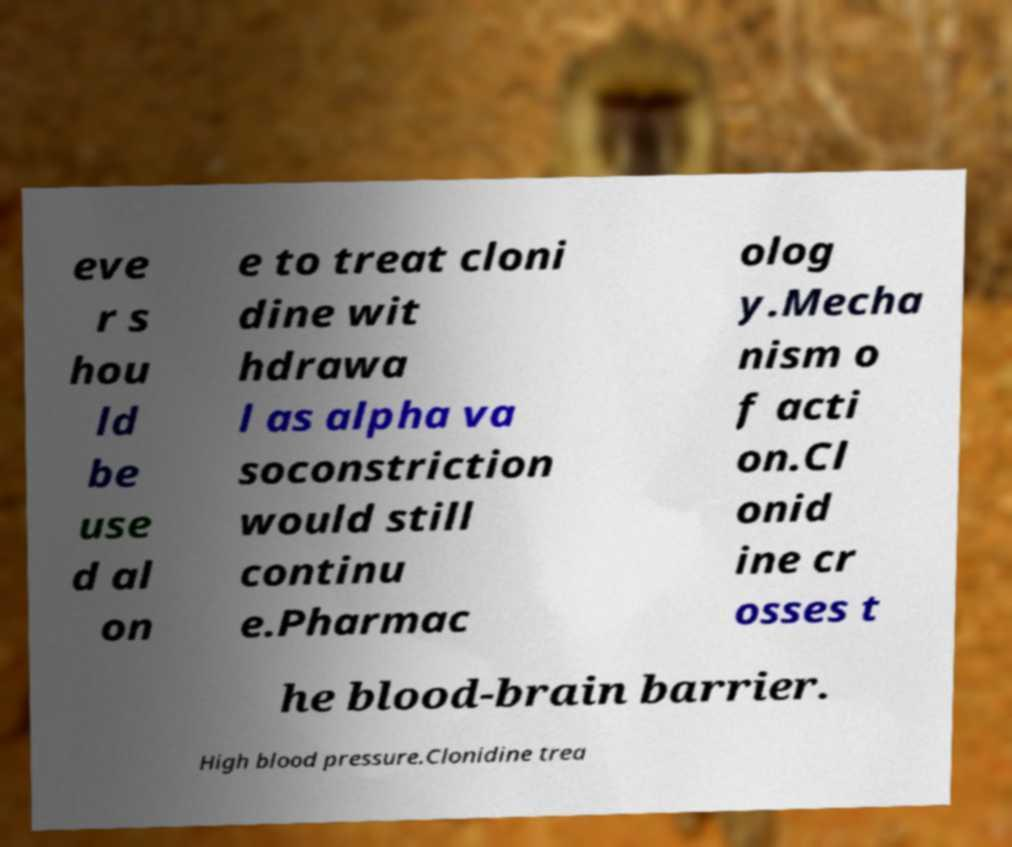Please read and relay the text visible in this image. What does it say? eve r s hou ld be use d al on e to treat cloni dine wit hdrawa l as alpha va soconstriction would still continu e.Pharmac olog y.Mecha nism o f acti on.Cl onid ine cr osses t he blood-brain barrier. High blood pressure.Clonidine trea 